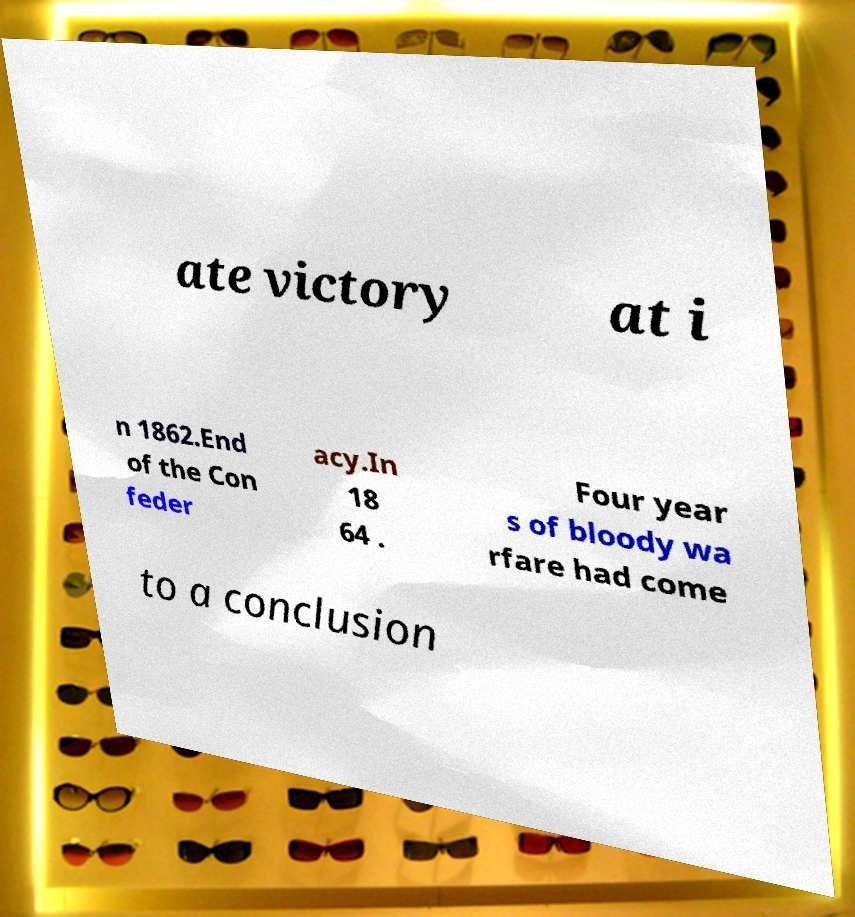Please read and relay the text visible in this image. What does it say? ate victory at i n 1862.End of the Con feder acy.In 18 64 . Four year s of bloody wa rfare had come to a conclusion 